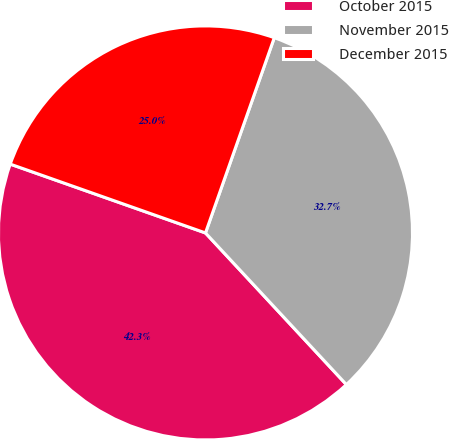<chart> <loc_0><loc_0><loc_500><loc_500><pie_chart><fcel>October 2015<fcel>November 2015<fcel>December 2015<nl><fcel>42.31%<fcel>32.69%<fcel>25.0%<nl></chart> 